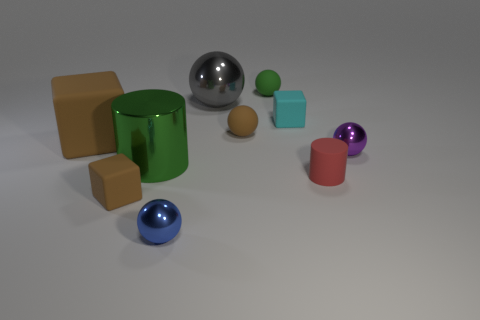There is a big green metallic object; are there any metallic balls behind it?
Make the answer very short. Yes. What is the color of the other shiny thing that is the same size as the blue shiny thing?
Your response must be concise. Purple. How many small green things are made of the same material as the green ball?
Provide a short and direct response. 0. What number of other things are there of the same size as the matte cylinder?
Offer a very short reply. 6. Are there any balls of the same size as the cyan block?
Give a very brief answer. Yes. There is a tiny block that is behind the large green metal object; is it the same color as the tiny cylinder?
Give a very brief answer. No. How many things are either big blue cubes or blue shiny balls?
Your answer should be very brief. 1. Is the size of the red rubber cylinder that is in front of the shiny cylinder the same as the green cylinder?
Your answer should be very brief. No. What is the size of the metallic ball that is both to the left of the tiny red rubber thing and behind the small red cylinder?
Offer a very short reply. Large. What number of other things are the same shape as the small purple thing?
Offer a terse response. 4. 